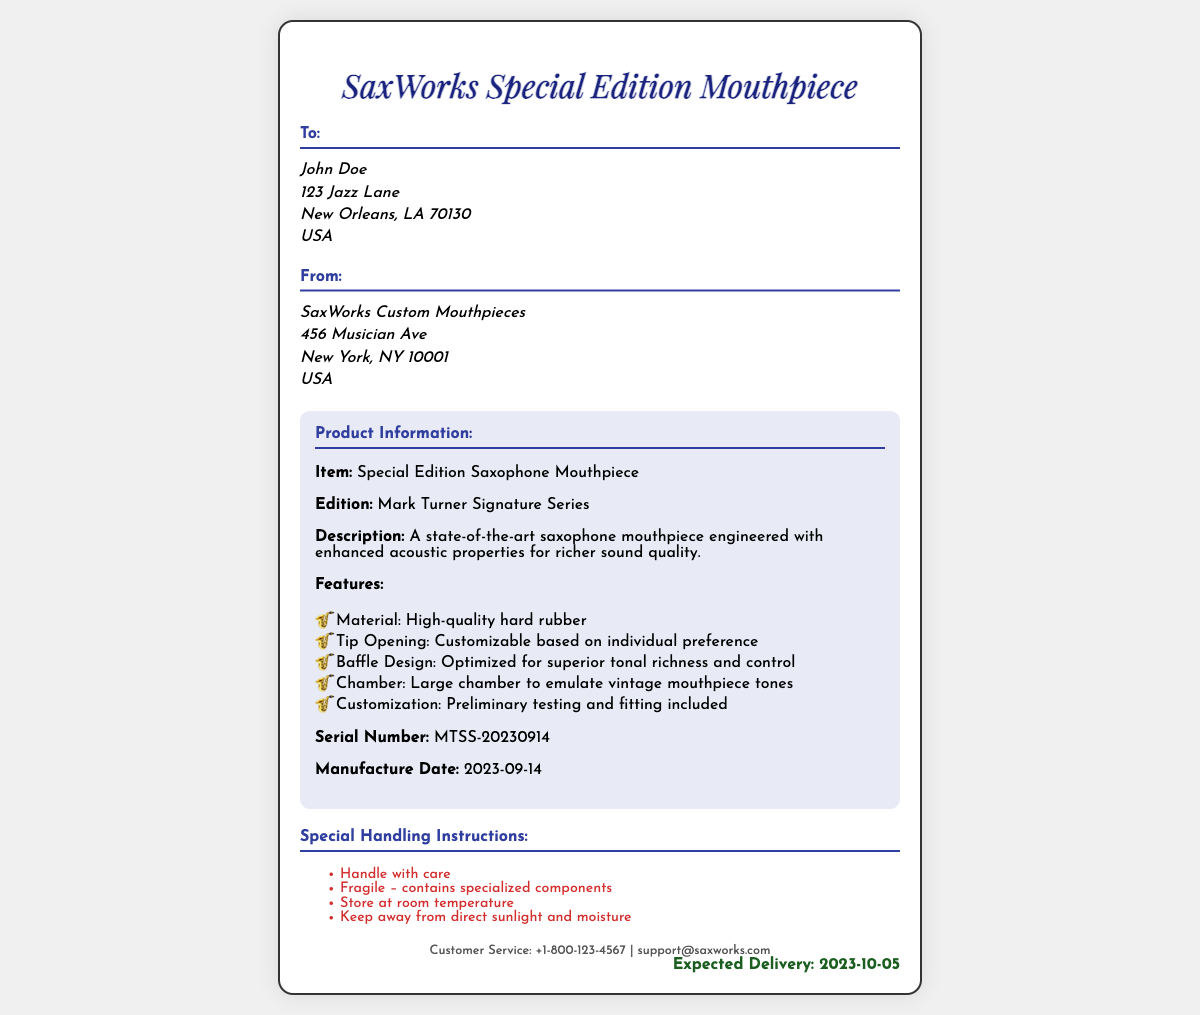What is the recipient's name? The recipient's name is clearly listed in the "To:" section of the document.
Answer: John Doe What is the expected delivery date? The expected delivery date is mentioned at the bottom of the document.
Answer: 2023-10-05 What is the product’s serial number? The serial number is provided in the product information section.
Answer: MTSS-20230914 What is the address of the sender? The sender's address is detailed in the "From:" section of the document.
Answer: 456 Musician Ave, New York, NY 10001, USA What special instructions are given for handling the product? The instructions for handling are prominently listed in their own section.
Answer: Handle with care What is the main material used in the mouthpiece? The material of the mouthpiece is mentioned in the product features list.
Answer: High-quality hard rubber Which series is the saxophone mouthpiece a part of? The series of the mouthpiece is indicated in the product information section.
Answer: Mark Turner Signature Series What should be avoided when storing the mouthpiece? Storage instructions specify what should be avoided when storing the mouthpiece.
Answer: Direct sunlight and moisture How large is the chamber of the mouthpiece designed to be? The chamber design is specified in the features of the product.
Answer: Large chamber 